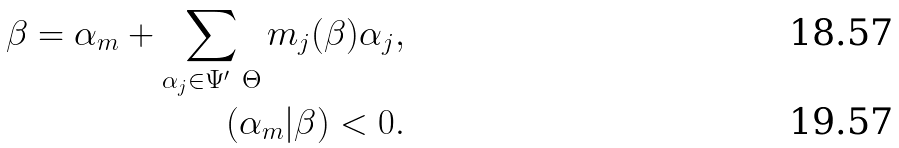<formula> <loc_0><loc_0><loc_500><loc_500>\beta = \alpha _ { m } + \sum _ { \alpha _ { j } \in \Psi ^ { \prime } \ \Theta } m _ { j } ( \beta ) \alpha _ { j } , \\ ( \alpha _ { m } | \beta ) < 0 .</formula> 